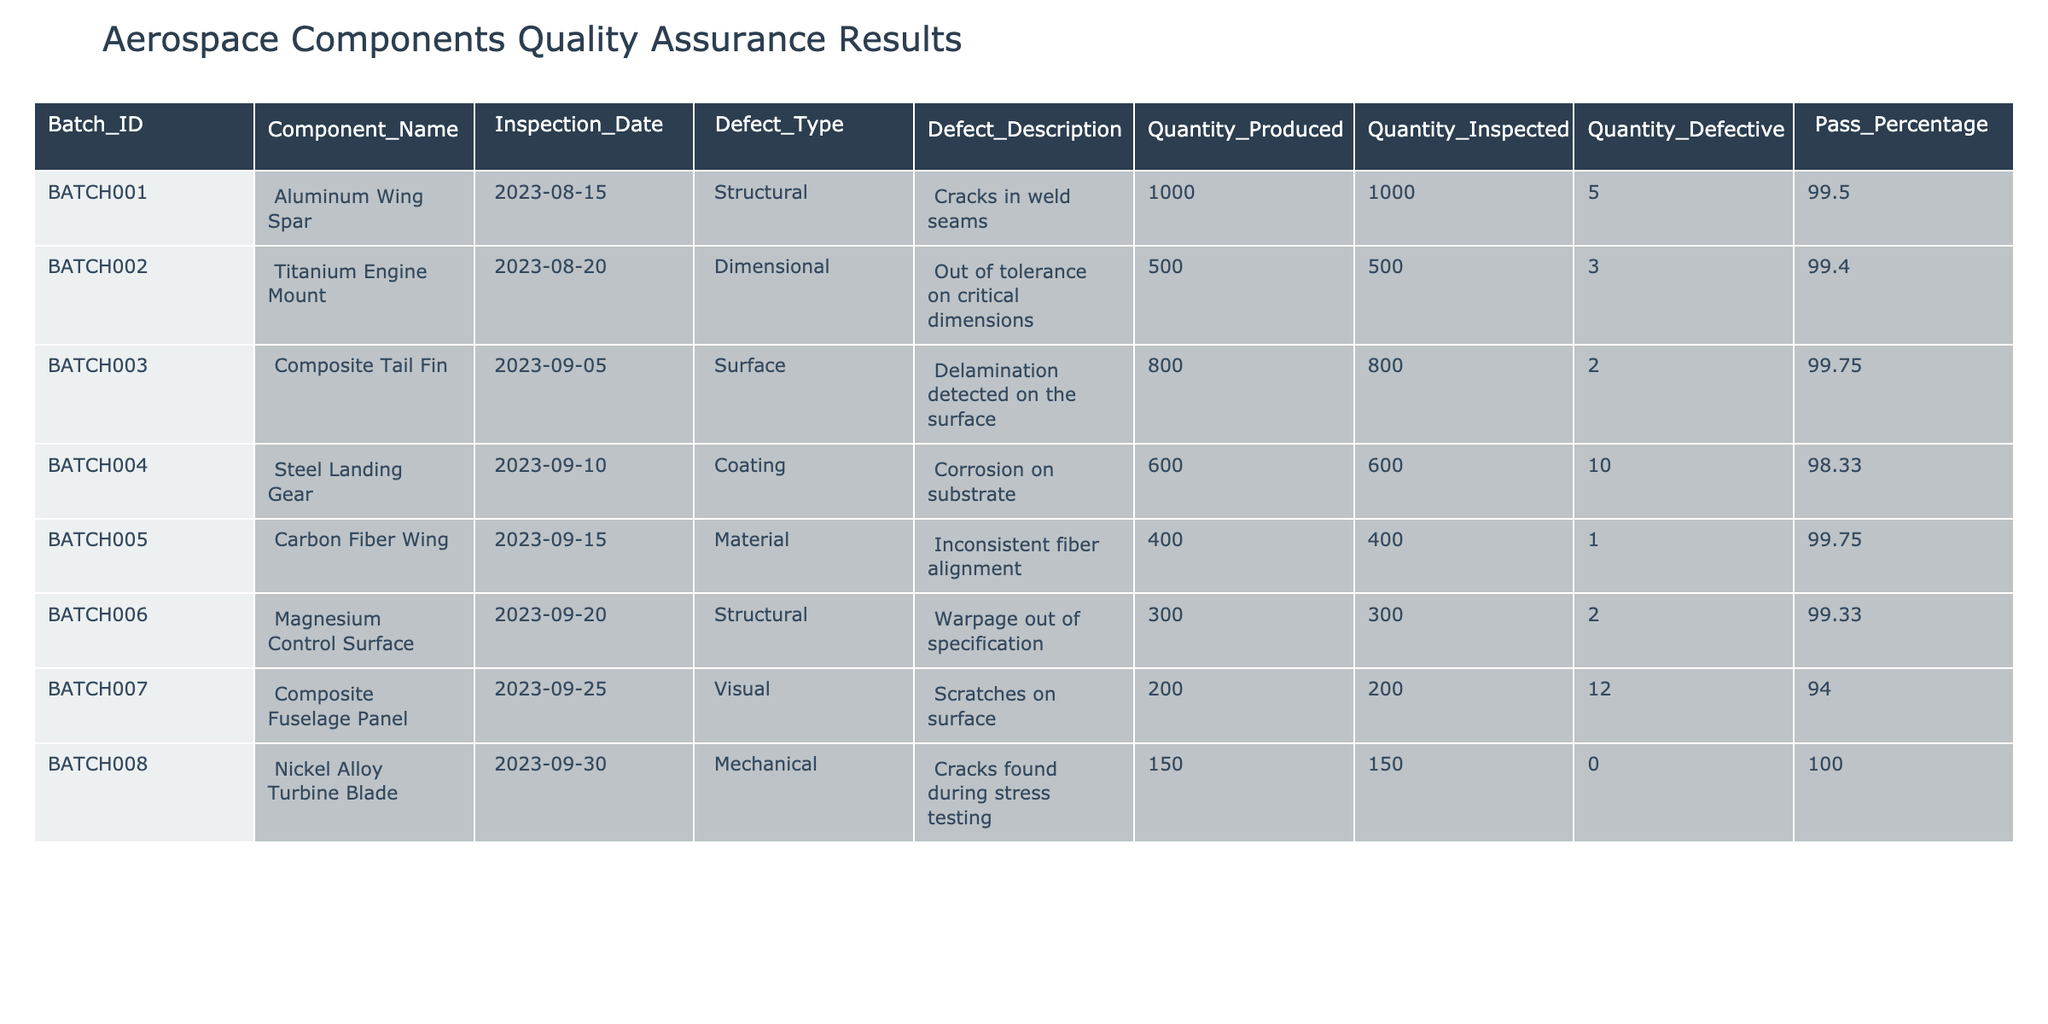What is the defect description for the Titanium Engine Mount? The table shows that the defect description for the Titanium Engine Mount is "Out of tolerance on critical dimensions."
Answer: Out of tolerance on critical dimensions How many defective components were found in the Composite Fuselage Panel batch? The table indicates that there were 12 defective components in the Composite Fuselage Panel batch.
Answer: 12 What is the pass percentage of the Steel Landing Gear? From the table, the Steel Landing Gear has a pass percentage of 98.33.
Answer: 98.33 Which component had the highest quantity produced and what was its pass percentage? By examining the table, we see that the Aluminum Wing Spar had the highest quantity produced at 1000 units, with a pass percentage of 99.50.
Answer: 1000 units, 99.50 What is the average pass percentage of all batches? The pass percentages are 99.50, 99.40, 99.75, 98.33, 99.75, 99.33, 94.00, and 100.00. Summing them gives 794.06 and dividing by 8 yields an average of 99.26.
Answer: 99.26 Is the defect description for the Carbon Fiber Wing related to surface issues? The defect description for the Carbon Fiber Wing is "Inconsistent fiber alignment," which does not relate to surface issues but rather to material quality.
Answer: No Was there any batch where no defective components were reported? The table lists the Nickel Alloy Turbine Blade, which shows 0 defective components, confirming that no defective components were reported for this batch.
Answer: Yes Which defect type had the fewest total defects across all batches? Counting the defects for each type: Structural (7), Dimensional (3), Surface (2), Coating (10), Material (1), Visual (12), Mechanical (0). The Material defect type had the fewest total defects with just 1.
Answer: Material What is the total quantity of components inspected across all batches? The total quantity inspected is calculated by summing the inspected quantities for all batches: 1000 + 500 + 800 + 600 + 400 + 300 + 200 + 150 = 4150.
Answer: 4150 